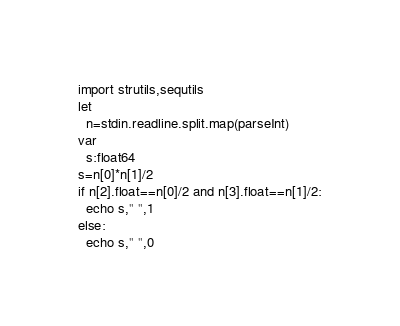Convert code to text. <code><loc_0><loc_0><loc_500><loc_500><_Nim_>import strutils,sequtils
let
  n=stdin.readline.split.map(parseInt)
var
  s:float64
s=n[0]*n[1]/2
if n[2].float==n[0]/2 and n[3].float==n[1]/2:
  echo s," ",1
else:
  echo s," ",0</code> 